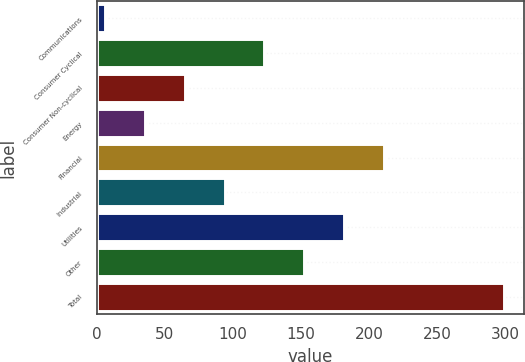<chart> <loc_0><loc_0><loc_500><loc_500><bar_chart><fcel>Communications<fcel>Consumer Cyclical<fcel>Consumer Non-cyclical<fcel>Energy<fcel>Financial<fcel>Industrial<fcel>Utilities<fcel>Other<fcel>Total<nl><fcel>6<fcel>123.2<fcel>64.6<fcel>35.3<fcel>211.1<fcel>93.9<fcel>181.8<fcel>152.5<fcel>299<nl></chart> 